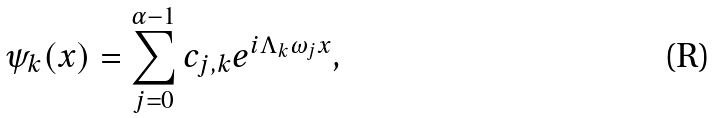<formula> <loc_0><loc_0><loc_500><loc_500>\psi _ { k } ( x ) = \sum _ { j = 0 } ^ { \alpha - 1 } c _ { j , k } e ^ { i \Lambda _ { k } \omega _ { j } x } ,</formula> 